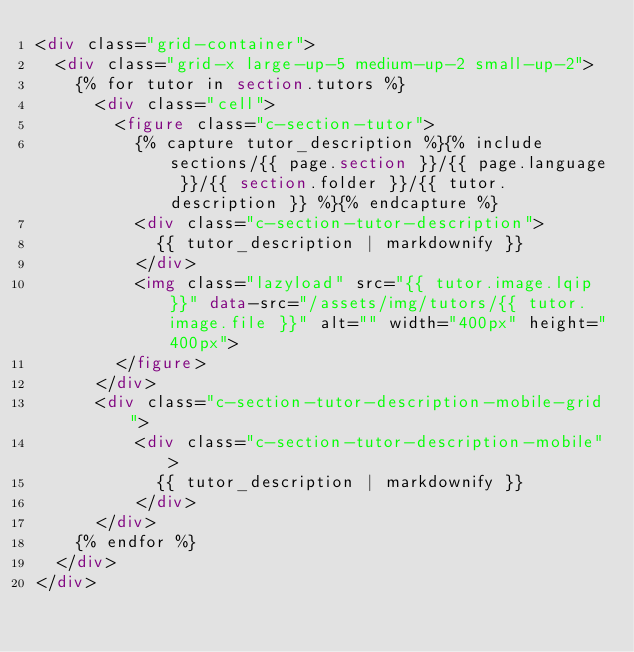Convert code to text. <code><loc_0><loc_0><loc_500><loc_500><_HTML_><div class="grid-container">
  <div class="grid-x large-up-5 medium-up-2 small-up-2">
    {% for tutor in section.tutors %}
      <div class="cell">
        <figure class="c-section-tutor">
          {% capture tutor_description %}{% include sections/{{ page.section }}/{{ page.language }}/{{ section.folder }}/{{ tutor.description }} %}{% endcapture %}
          <div class="c-section-tutor-description">
            {{ tutor_description | markdownify }}
          </div>
          <img class="lazyload" src="{{ tutor.image.lqip }}" data-src="/assets/img/tutors/{{ tutor.image.file }}" alt="" width="400px" height="400px">
        </figure>
      </div>
      <div class="c-section-tutor-description-mobile-grid">
          <div class="c-section-tutor-description-mobile">
            {{ tutor_description | markdownify }}
          </div>
      </div>
    {% endfor %}
  </div>
</div>
</code> 